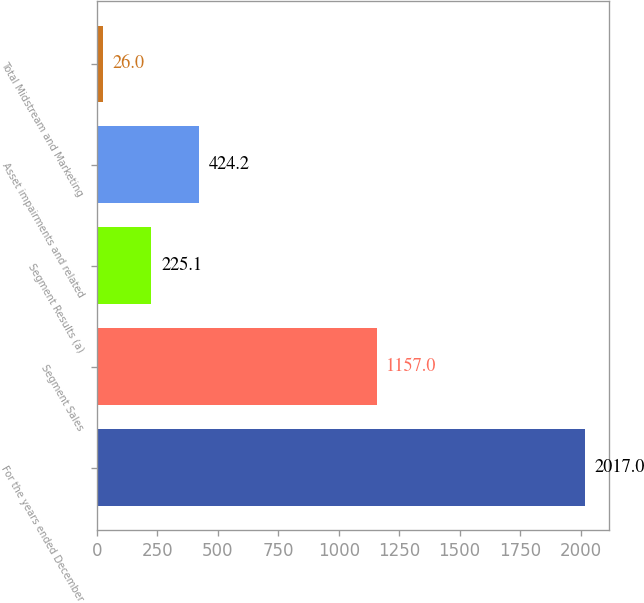Convert chart to OTSL. <chart><loc_0><loc_0><loc_500><loc_500><bar_chart><fcel>For the years ended December<fcel>Segment Sales<fcel>Segment Results (a)<fcel>Asset impairments and related<fcel>Total Midstream and Marketing<nl><fcel>2017<fcel>1157<fcel>225.1<fcel>424.2<fcel>26<nl></chart> 